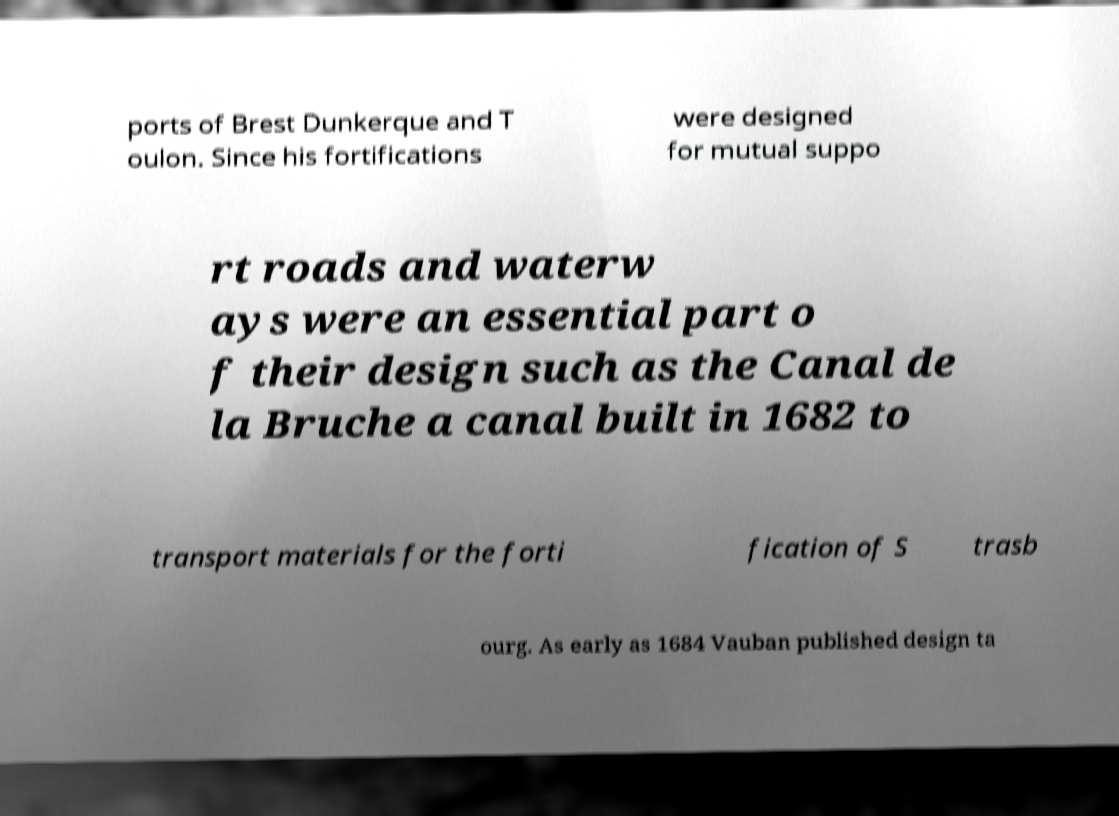What messages or text are displayed in this image? I need them in a readable, typed format. ports of Brest Dunkerque and T oulon. Since his fortifications were designed for mutual suppo rt roads and waterw ays were an essential part o f their design such as the Canal de la Bruche a canal built in 1682 to transport materials for the forti fication of S trasb ourg. As early as 1684 Vauban published design ta 